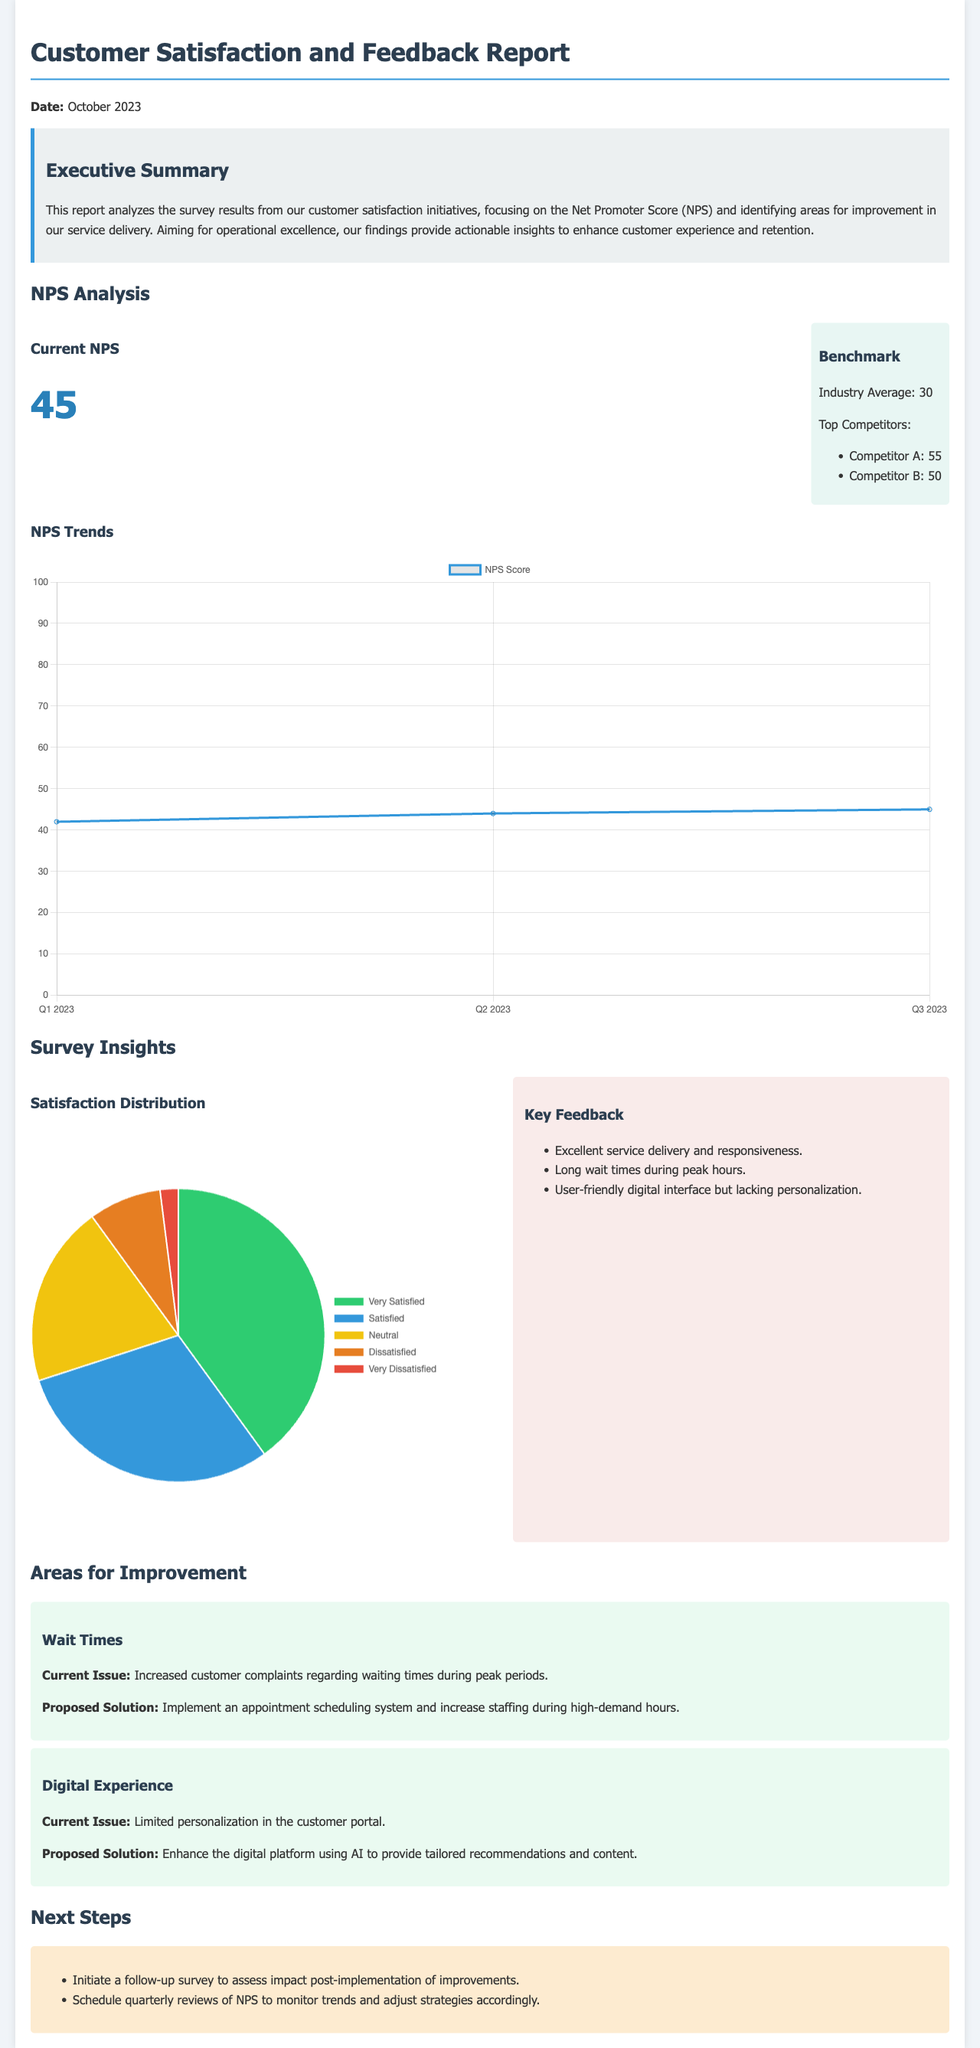What is the current NPS? The current NPS is presented prominently in the NPS analysis section, indicating how satisfied customers are with the service.
Answer: 45 What is the industry average for NPS? The document mentions the industry average for NPS as a benchmark to evaluate the company's performance against its competitors.
Answer: 30 What were the wait times characterized as in the report? The report identifies wait times as a critical area for improvement, indicating increased complaints from customers.
Answer: Increased customer complaints Which competitor has the highest NPS? The report lists competitors and their respective NPS scores, helping to position the company's performance in relation to market peers.
Answer: Competitor A: 55 What proposed solution aims to enhance the digital experience? The document suggests initiatives for improvement in digital experience, specifically targeting enhancements to the customer portal.
Answer: Enhance the digital platform using AI What percentage of customers are very satisfied? Satisfaction distribution data is visualized to showcase how clients feel about the service, necessary for a comprehensive understanding of customer sentiment.
Answer: 200 What is one area identified for improvement in service delivery? The report highlights specific areas needing attention to improve the overall customer experience based on feedback received.
Answer: Wait Times What is the proposed follow-up action after implementing improvements? The document outlines next steps regarding how to assess the effectiveness of changes made in response to customer feedback.
Answer: Initiate a follow-up survey 